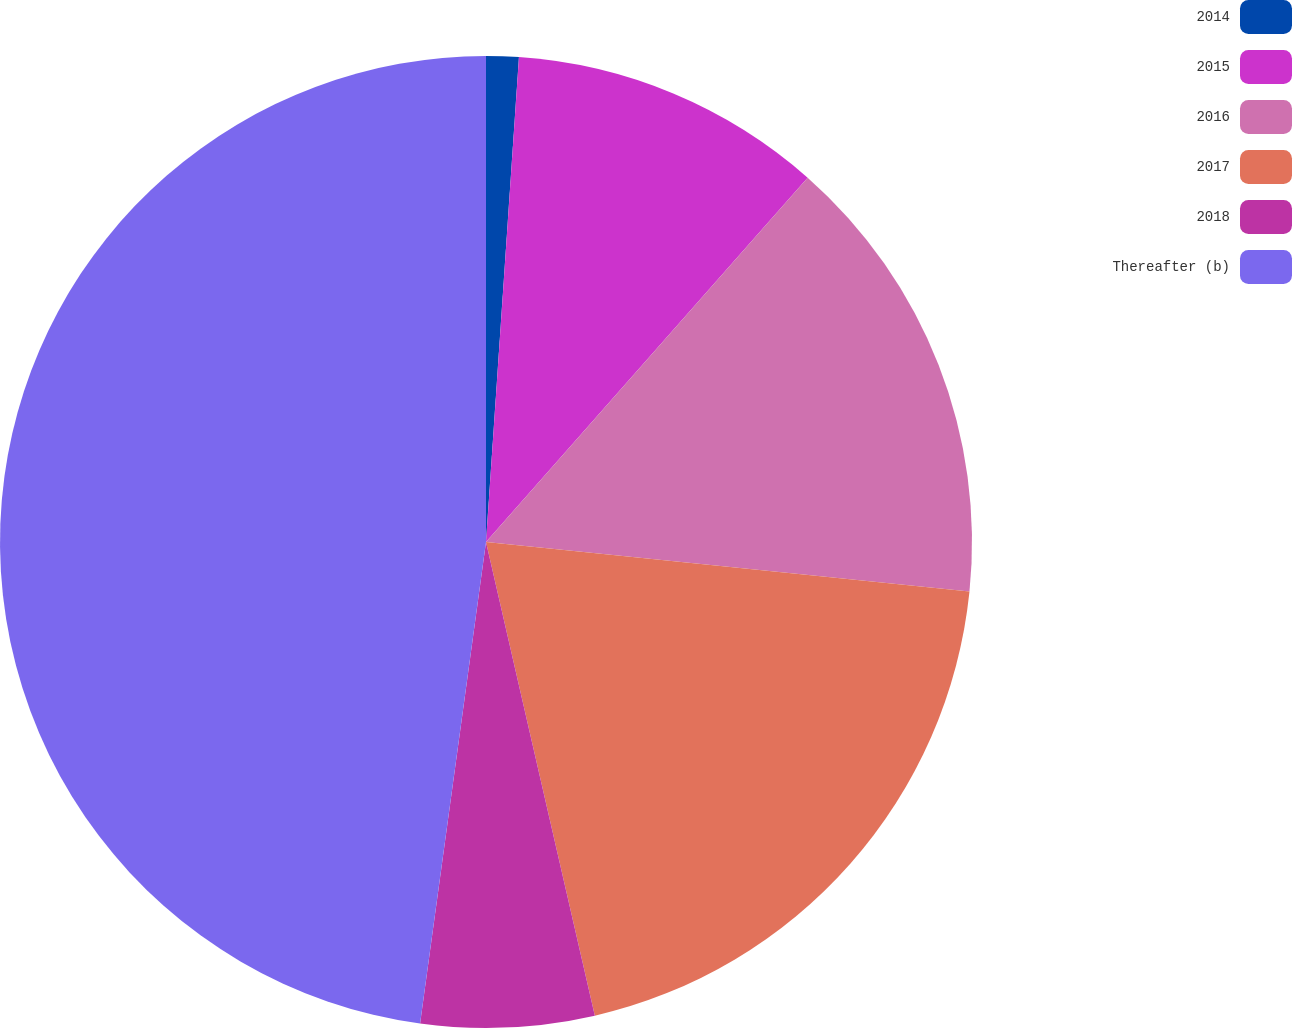Convert chart. <chart><loc_0><loc_0><loc_500><loc_500><pie_chart><fcel>2014<fcel>2015<fcel>2016<fcel>2017<fcel>2018<fcel>Thereafter (b)<nl><fcel>1.08%<fcel>10.43%<fcel>15.11%<fcel>19.78%<fcel>5.76%<fcel>47.83%<nl></chart> 